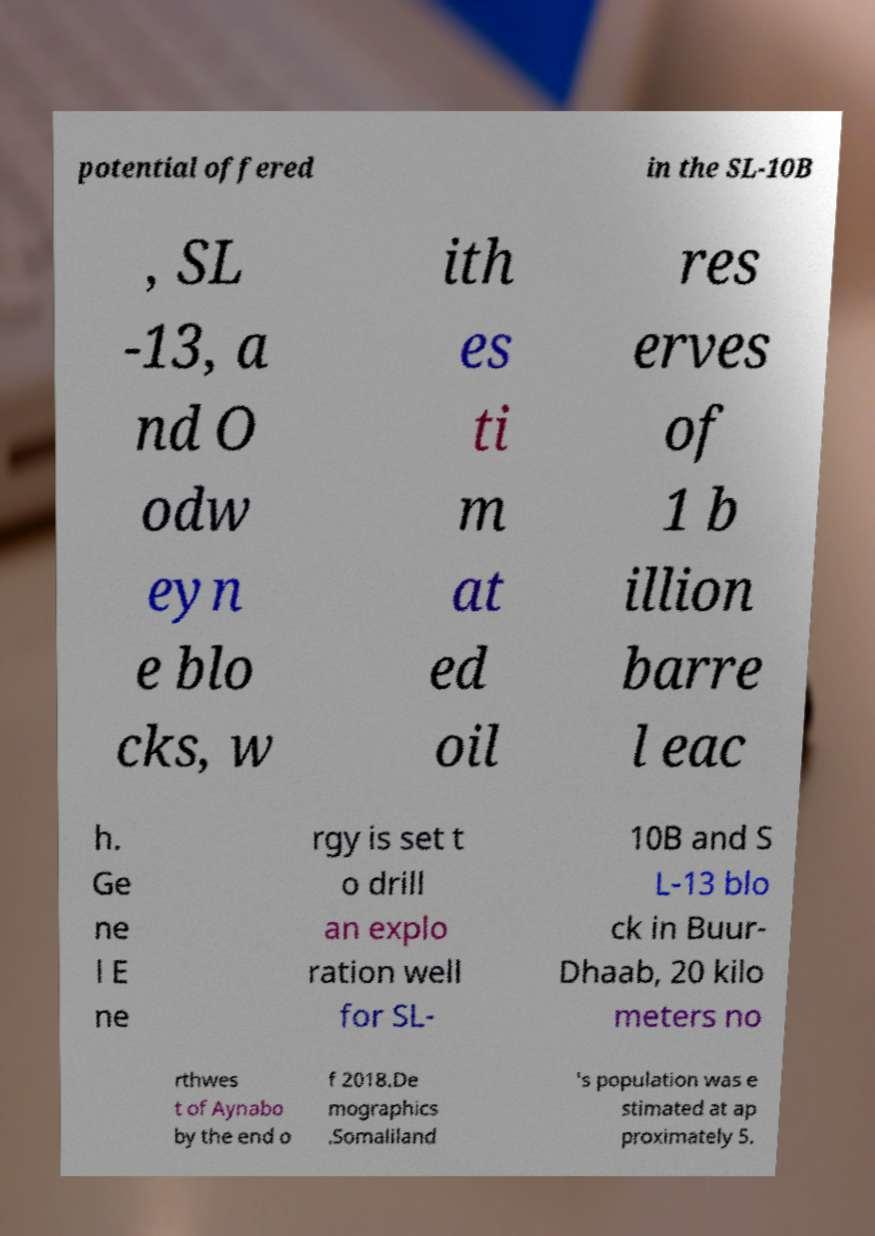Could you assist in decoding the text presented in this image and type it out clearly? potential offered in the SL-10B , SL -13, a nd O odw eyn e blo cks, w ith es ti m at ed oil res erves of 1 b illion barre l eac h. Ge ne l E ne rgy is set t o drill an explo ration well for SL- 10B and S L-13 blo ck in Buur- Dhaab, 20 kilo meters no rthwes t of Aynabo by the end o f 2018.De mographics .Somaliland 's population was e stimated at ap proximately 5. 